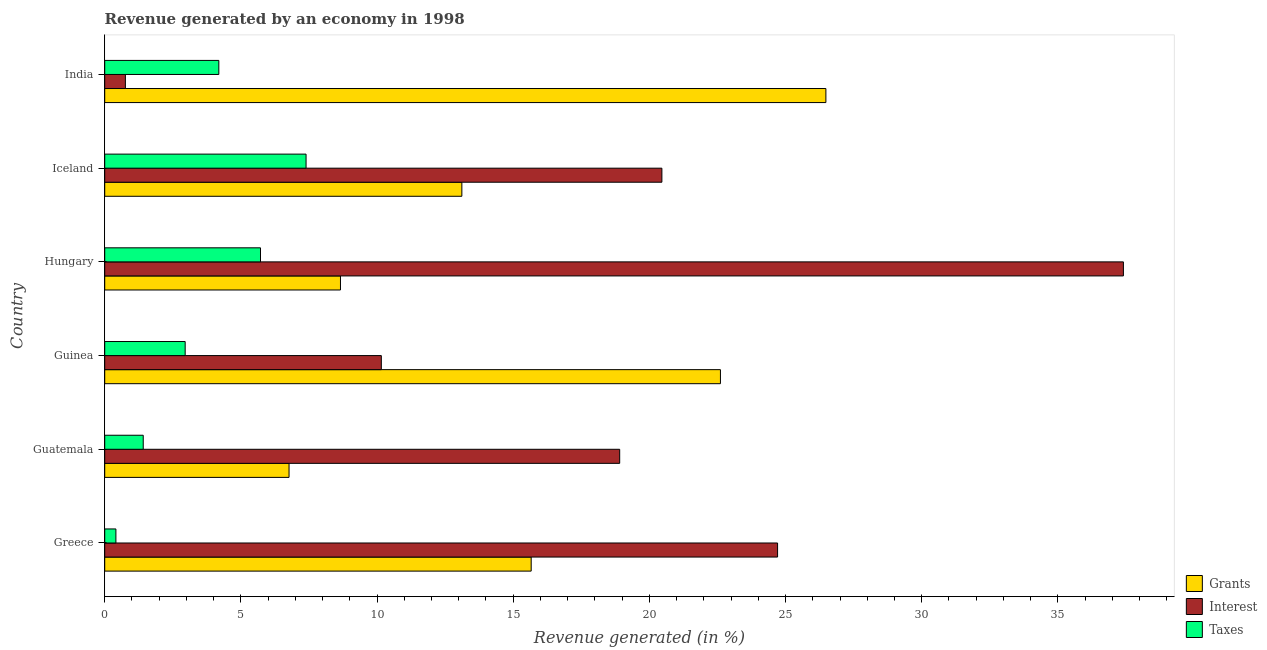How many groups of bars are there?
Give a very brief answer. 6. Are the number of bars on each tick of the Y-axis equal?
Offer a very short reply. Yes. What is the label of the 3rd group of bars from the top?
Provide a short and direct response. Hungary. What is the percentage of revenue generated by taxes in Guatemala?
Give a very brief answer. 1.41. Across all countries, what is the maximum percentage of revenue generated by interest?
Provide a short and direct response. 37.41. Across all countries, what is the minimum percentage of revenue generated by taxes?
Keep it short and to the point. 0.41. In which country was the percentage of revenue generated by grants maximum?
Ensure brevity in your answer.  India. In which country was the percentage of revenue generated by interest minimum?
Keep it short and to the point. India. What is the total percentage of revenue generated by interest in the graph?
Provide a succinct answer. 112.4. What is the difference between the percentage of revenue generated by taxes in Guinea and that in India?
Your response must be concise. -1.24. What is the difference between the percentage of revenue generated by grants in Greece and the percentage of revenue generated by taxes in Iceland?
Ensure brevity in your answer.  8.27. What is the average percentage of revenue generated by grants per country?
Give a very brief answer. 15.55. What is the difference between the percentage of revenue generated by taxes and percentage of revenue generated by grants in Greece?
Your answer should be compact. -15.25. In how many countries, is the percentage of revenue generated by grants greater than 26 %?
Your answer should be very brief. 1. What is the ratio of the percentage of revenue generated by taxes in Guatemala to that in India?
Give a very brief answer. 0.34. Is the difference between the percentage of revenue generated by taxes in Greece and India greater than the difference between the percentage of revenue generated by interest in Greece and India?
Give a very brief answer. No. What is the difference between the highest and the second highest percentage of revenue generated by interest?
Your answer should be compact. 12.7. What is the difference between the highest and the lowest percentage of revenue generated by grants?
Your response must be concise. 19.71. Is the sum of the percentage of revenue generated by grants in Hungary and Iceland greater than the maximum percentage of revenue generated by interest across all countries?
Offer a terse response. No. What does the 2nd bar from the top in Guatemala represents?
Your answer should be compact. Interest. What does the 2nd bar from the bottom in Guatemala represents?
Your response must be concise. Interest. Is it the case that in every country, the sum of the percentage of revenue generated by grants and percentage of revenue generated by interest is greater than the percentage of revenue generated by taxes?
Offer a very short reply. Yes. What is the difference between two consecutive major ticks on the X-axis?
Offer a very short reply. 5. Are the values on the major ticks of X-axis written in scientific E-notation?
Provide a short and direct response. No. Does the graph contain any zero values?
Ensure brevity in your answer.  No. What is the title of the graph?
Ensure brevity in your answer.  Revenue generated by an economy in 1998. Does "Ireland" appear as one of the legend labels in the graph?
Give a very brief answer. No. What is the label or title of the X-axis?
Your answer should be very brief. Revenue generated (in %). What is the Revenue generated (in %) of Grants in Greece?
Offer a terse response. 15.66. What is the Revenue generated (in %) in Interest in Greece?
Offer a terse response. 24.71. What is the Revenue generated (in %) of Taxes in Greece?
Your answer should be compact. 0.41. What is the Revenue generated (in %) in Grants in Guatemala?
Give a very brief answer. 6.77. What is the Revenue generated (in %) in Interest in Guatemala?
Offer a very short reply. 18.91. What is the Revenue generated (in %) of Taxes in Guatemala?
Ensure brevity in your answer.  1.41. What is the Revenue generated (in %) in Grants in Guinea?
Make the answer very short. 22.61. What is the Revenue generated (in %) in Interest in Guinea?
Your answer should be compact. 10.16. What is the Revenue generated (in %) of Taxes in Guinea?
Provide a succinct answer. 2.95. What is the Revenue generated (in %) of Grants in Hungary?
Give a very brief answer. 8.66. What is the Revenue generated (in %) in Interest in Hungary?
Ensure brevity in your answer.  37.41. What is the Revenue generated (in %) in Taxes in Hungary?
Provide a succinct answer. 5.72. What is the Revenue generated (in %) in Grants in Iceland?
Make the answer very short. 13.11. What is the Revenue generated (in %) in Interest in Iceland?
Offer a very short reply. 20.46. What is the Revenue generated (in %) of Taxes in Iceland?
Your answer should be very brief. 7.39. What is the Revenue generated (in %) of Grants in India?
Ensure brevity in your answer.  26.48. What is the Revenue generated (in %) in Interest in India?
Provide a short and direct response. 0.76. What is the Revenue generated (in %) of Taxes in India?
Offer a terse response. 4.19. Across all countries, what is the maximum Revenue generated (in %) of Grants?
Give a very brief answer. 26.48. Across all countries, what is the maximum Revenue generated (in %) in Interest?
Your answer should be very brief. 37.41. Across all countries, what is the maximum Revenue generated (in %) of Taxes?
Make the answer very short. 7.39. Across all countries, what is the minimum Revenue generated (in %) of Grants?
Offer a terse response. 6.77. Across all countries, what is the minimum Revenue generated (in %) of Interest?
Your response must be concise. 0.76. Across all countries, what is the minimum Revenue generated (in %) in Taxes?
Ensure brevity in your answer.  0.41. What is the total Revenue generated (in %) of Grants in the graph?
Your response must be concise. 93.29. What is the total Revenue generated (in %) in Interest in the graph?
Make the answer very short. 112.4. What is the total Revenue generated (in %) of Taxes in the graph?
Offer a very short reply. 22.08. What is the difference between the Revenue generated (in %) of Grants in Greece and that in Guatemala?
Keep it short and to the point. 8.89. What is the difference between the Revenue generated (in %) of Interest in Greece and that in Guatemala?
Ensure brevity in your answer.  5.8. What is the difference between the Revenue generated (in %) of Taxes in Greece and that in Guatemala?
Offer a terse response. -1. What is the difference between the Revenue generated (in %) in Grants in Greece and that in Guinea?
Offer a very short reply. -6.95. What is the difference between the Revenue generated (in %) of Interest in Greece and that in Guinea?
Your response must be concise. 14.55. What is the difference between the Revenue generated (in %) in Taxes in Greece and that in Guinea?
Give a very brief answer. -2.54. What is the difference between the Revenue generated (in %) in Grants in Greece and that in Hungary?
Your response must be concise. 7. What is the difference between the Revenue generated (in %) of Interest in Greece and that in Hungary?
Your answer should be compact. -12.7. What is the difference between the Revenue generated (in %) in Taxes in Greece and that in Hungary?
Keep it short and to the point. -5.31. What is the difference between the Revenue generated (in %) in Grants in Greece and that in Iceland?
Make the answer very short. 2.55. What is the difference between the Revenue generated (in %) in Interest in Greece and that in Iceland?
Offer a terse response. 4.25. What is the difference between the Revenue generated (in %) of Taxes in Greece and that in Iceland?
Provide a succinct answer. -6.98. What is the difference between the Revenue generated (in %) of Grants in Greece and that in India?
Give a very brief answer. -10.82. What is the difference between the Revenue generated (in %) in Interest in Greece and that in India?
Offer a very short reply. 23.95. What is the difference between the Revenue generated (in %) in Taxes in Greece and that in India?
Your answer should be very brief. -3.78. What is the difference between the Revenue generated (in %) in Grants in Guatemala and that in Guinea?
Make the answer very short. -15.84. What is the difference between the Revenue generated (in %) of Interest in Guatemala and that in Guinea?
Make the answer very short. 8.75. What is the difference between the Revenue generated (in %) in Taxes in Guatemala and that in Guinea?
Keep it short and to the point. -1.54. What is the difference between the Revenue generated (in %) in Grants in Guatemala and that in Hungary?
Offer a very short reply. -1.89. What is the difference between the Revenue generated (in %) in Interest in Guatemala and that in Hungary?
Offer a terse response. -18.5. What is the difference between the Revenue generated (in %) of Taxes in Guatemala and that in Hungary?
Keep it short and to the point. -4.31. What is the difference between the Revenue generated (in %) of Grants in Guatemala and that in Iceland?
Your answer should be compact. -6.35. What is the difference between the Revenue generated (in %) of Interest in Guatemala and that in Iceland?
Provide a succinct answer. -1.55. What is the difference between the Revenue generated (in %) of Taxes in Guatemala and that in Iceland?
Your answer should be very brief. -5.98. What is the difference between the Revenue generated (in %) in Grants in Guatemala and that in India?
Ensure brevity in your answer.  -19.71. What is the difference between the Revenue generated (in %) in Interest in Guatemala and that in India?
Keep it short and to the point. 18.15. What is the difference between the Revenue generated (in %) in Taxes in Guatemala and that in India?
Provide a succinct answer. -2.78. What is the difference between the Revenue generated (in %) of Grants in Guinea and that in Hungary?
Provide a succinct answer. 13.95. What is the difference between the Revenue generated (in %) in Interest in Guinea and that in Hungary?
Offer a very short reply. -27.25. What is the difference between the Revenue generated (in %) in Taxes in Guinea and that in Hungary?
Your response must be concise. -2.77. What is the difference between the Revenue generated (in %) in Grants in Guinea and that in Iceland?
Provide a short and direct response. 9.49. What is the difference between the Revenue generated (in %) of Interest in Guinea and that in Iceland?
Your answer should be compact. -10.3. What is the difference between the Revenue generated (in %) in Taxes in Guinea and that in Iceland?
Offer a terse response. -4.44. What is the difference between the Revenue generated (in %) of Grants in Guinea and that in India?
Offer a very short reply. -3.87. What is the difference between the Revenue generated (in %) in Interest in Guinea and that in India?
Your answer should be very brief. 9.4. What is the difference between the Revenue generated (in %) of Taxes in Guinea and that in India?
Your answer should be compact. -1.24. What is the difference between the Revenue generated (in %) of Grants in Hungary and that in Iceland?
Ensure brevity in your answer.  -4.46. What is the difference between the Revenue generated (in %) in Interest in Hungary and that in Iceland?
Provide a short and direct response. 16.95. What is the difference between the Revenue generated (in %) of Taxes in Hungary and that in Iceland?
Keep it short and to the point. -1.67. What is the difference between the Revenue generated (in %) of Grants in Hungary and that in India?
Your response must be concise. -17.82. What is the difference between the Revenue generated (in %) of Interest in Hungary and that in India?
Your answer should be very brief. 36.65. What is the difference between the Revenue generated (in %) in Taxes in Hungary and that in India?
Keep it short and to the point. 1.53. What is the difference between the Revenue generated (in %) of Grants in Iceland and that in India?
Keep it short and to the point. -13.37. What is the difference between the Revenue generated (in %) in Interest in Iceland and that in India?
Keep it short and to the point. 19.7. What is the difference between the Revenue generated (in %) of Taxes in Iceland and that in India?
Your answer should be compact. 3.2. What is the difference between the Revenue generated (in %) of Grants in Greece and the Revenue generated (in %) of Interest in Guatemala?
Make the answer very short. -3.25. What is the difference between the Revenue generated (in %) of Grants in Greece and the Revenue generated (in %) of Taxes in Guatemala?
Make the answer very short. 14.25. What is the difference between the Revenue generated (in %) of Interest in Greece and the Revenue generated (in %) of Taxes in Guatemala?
Give a very brief answer. 23.29. What is the difference between the Revenue generated (in %) of Grants in Greece and the Revenue generated (in %) of Interest in Guinea?
Provide a short and direct response. 5.5. What is the difference between the Revenue generated (in %) in Grants in Greece and the Revenue generated (in %) in Taxes in Guinea?
Offer a very short reply. 12.71. What is the difference between the Revenue generated (in %) of Interest in Greece and the Revenue generated (in %) of Taxes in Guinea?
Give a very brief answer. 21.75. What is the difference between the Revenue generated (in %) of Grants in Greece and the Revenue generated (in %) of Interest in Hungary?
Offer a terse response. -21.75. What is the difference between the Revenue generated (in %) in Grants in Greece and the Revenue generated (in %) in Taxes in Hungary?
Ensure brevity in your answer.  9.94. What is the difference between the Revenue generated (in %) in Interest in Greece and the Revenue generated (in %) in Taxes in Hungary?
Your answer should be compact. 18.99. What is the difference between the Revenue generated (in %) of Grants in Greece and the Revenue generated (in %) of Interest in Iceland?
Your answer should be very brief. -4.8. What is the difference between the Revenue generated (in %) in Grants in Greece and the Revenue generated (in %) in Taxes in Iceland?
Provide a short and direct response. 8.27. What is the difference between the Revenue generated (in %) in Interest in Greece and the Revenue generated (in %) in Taxes in Iceland?
Offer a terse response. 17.31. What is the difference between the Revenue generated (in %) in Grants in Greece and the Revenue generated (in %) in Interest in India?
Give a very brief answer. 14.9. What is the difference between the Revenue generated (in %) in Grants in Greece and the Revenue generated (in %) in Taxes in India?
Make the answer very short. 11.47. What is the difference between the Revenue generated (in %) of Interest in Greece and the Revenue generated (in %) of Taxes in India?
Keep it short and to the point. 20.52. What is the difference between the Revenue generated (in %) in Grants in Guatemala and the Revenue generated (in %) in Interest in Guinea?
Ensure brevity in your answer.  -3.39. What is the difference between the Revenue generated (in %) of Grants in Guatemala and the Revenue generated (in %) of Taxes in Guinea?
Give a very brief answer. 3.81. What is the difference between the Revenue generated (in %) of Interest in Guatemala and the Revenue generated (in %) of Taxes in Guinea?
Your answer should be very brief. 15.96. What is the difference between the Revenue generated (in %) in Grants in Guatemala and the Revenue generated (in %) in Interest in Hungary?
Provide a succinct answer. -30.64. What is the difference between the Revenue generated (in %) of Grants in Guatemala and the Revenue generated (in %) of Taxes in Hungary?
Your answer should be very brief. 1.05. What is the difference between the Revenue generated (in %) of Interest in Guatemala and the Revenue generated (in %) of Taxes in Hungary?
Your answer should be compact. 13.19. What is the difference between the Revenue generated (in %) of Grants in Guatemala and the Revenue generated (in %) of Interest in Iceland?
Offer a very short reply. -13.69. What is the difference between the Revenue generated (in %) in Grants in Guatemala and the Revenue generated (in %) in Taxes in Iceland?
Keep it short and to the point. -0.62. What is the difference between the Revenue generated (in %) in Interest in Guatemala and the Revenue generated (in %) in Taxes in Iceland?
Give a very brief answer. 11.52. What is the difference between the Revenue generated (in %) in Grants in Guatemala and the Revenue generated (in %) in Interest in India?
Ensure brevity in your answer.  6.01. What is the difference between the Revenue generated (in %) in Grants in Guatemala and the Revenue generated (in %) in Taxes in India?
Provide a short and direct response. 2.58. What is the difference between the Revenue generated (in %) in Interest in Guatemala and the Revenue generated (in %) in Taxes in India?
Provide a short and direct response. 14.72. What is the difference between the Revenue generated (in %) of Grants in Guinea and the Revenue generated (in %) of Interest in Hungary?
Offer a terse response. -14.8. What is the difference between the Revenue generated (in %) of Grants in Guinea and the Revenue generated (in %) of Taxes in Hungary?
Your response must be concise. 16.89. What is the difference between the Revenue generated (in %) of Interest in Guinea and the Revenue generated (in %) of Taxes in Hungary?
Your answer should be very brief. 4.44. What is the difference between the Revenue generated (in %) of Grants in Guinea and the Revenue generated (in %) of Interest in Iceland?
Keep it short and to the point. 2.15. What is the difference between the Revenue generated (in %) in Grants in Guinea and the Revenue generated (in %) in Taxes in Iceland?
Your answer should be compact. 15.22. What is the difference between the Revenue generated (in %) in Interest in Guinea and the Revenue generated (in %) in Taxes in Iceland?
Your answer should be very brief. 2.76. What is the difference between the Revenue generated (in %) in Grants in Guinea and the Revenue generated (in %) in Interest in India?
Your response must be concise. 21.85. What is the difference between the Revenue generated (in %) of Grants in Guinea and the Revenue generated (in %) of Taxes in India?
Give a very brief answer. 18.42. What is the difference between the Revenue generated (in %) of Interest in Guinea and the Revenue generated (in %) of Taxes in India?
Keep it short and to the point. 5.97. What is the difference between the Revenue generated (in %) in Grants in Hungary and the Revenue generated (in %) in Interest in Iceland?
Your response must be concise. -11.8. What is the difference between the Revenue generated (in %) of Grants in Hungary and the Revenue generated (in %) of Taxes in Iceland?
Provide a succinct answer. 1.26. What is the difference between the Revenue generated (in %) in Interest in Hungary and the Revenue generated (in %) in Taxes in Iceland?
Make the answer very short. 30.01. What is the difference between the Revenue generated (in %) in Grants in Hungary and the Revenue generated (in %) in Interest in India?
Provide a short and direct response. 7.9. What is the difference between the Revenue generated (in %) in Grants in Hungary and the Revenue generated (in %) in Taxes in India?
Ensure brevity in your answer.  4.47. What is the difference between the Revenue generated (in %) of Interest in Hungary and the Revenue generated (in %) of Taxes in India?
Provide a short and direct response. 33.22. What is the difference between the Revenue generated (in %) in Grants in Iceland and the Revenue generated (in %) in Interest in India?
Make the answer very short. 12.35. What is the difference between the Revenue generated (in %) in Grants in Iceland and the Revenue generated (in %) in Taxes in India?
Your answer should be very brief. 8.92. What is the difference between the Revenue generated (in %) in Interest in Iceland and the Revenue generated (in %) in Taxes in India?
Your answer should be compact. 16.27. What is the average Revenue generated (in %) of Grants per country?
Keep it short and to the point. 15.55. What is the average Revenue generated (in %) of Interest per country?
Your response must be concise. 18.73. What is the average Revenue generated (in %) in Taxes per country?
Give a very brief answer. 3.68. What is the difference between the Revenue generated (in %) of Grants and Revenue generated (in %) of Interest in Greece?
Give a very brief answer. -9.05. What is the difference between the Revenue generated (in %) in Grants and Revenue generated (in %) in Taxes in Greece?
Make the answer very short. 15.25. What is the difference between the Revenue generated (in %) in Interest and Revenue generated (in %) in Taxes in Greece?
Your answer should be compact. 24.3. What is the difference between the Revenue generated (in %) of Grants and Revenue generated (in %) of Interest in Guatemala?
Keep it short and to the point. -12.14. What is the difference between the Revenue generated (in %) of Grants and Revenue generated (in %) of Taxes in Guatemala?
Give a very brief answer. 5.35. What is the difference between the Revenue generated (in %) in Interest and Revenue generated (in %) in Taxes in Guatemala?
Give a very brief answer. 17.5. What is the difference between the Revenue generated (in %) in Grants and Revenue generated (in %) in Interest in Guinea?
Your answer should be compact. 12.45. What is the difference between the Revenue generated (in %) in Grants and Revenue generated (in %) in Taxes in Guinea?
Ensure brevity in your answer.  19.66. What is the difference between the Revenue generated (in %) in Interest and Revenue generated (in %) in Taxes in Guinea?
Offer a terse response. 7.2. What is the difference between the Revenue generated (in %) in Grants and Revenue generated (in %) in Interest in Hungary?
Offer a terse response. -28.75. What is the difference between the Revenue generated (in %) of Grants and Revenue generated (in %) of Taxes in Hungary?
Your response must be concise. 2.94. What is the difference between the Revenue generated (in %) of Interest and Revenue generated (in %) of Taxes in Hungary?
Keep it short and to the point. 31.68. What is the difference between the Revenue generated (in %) in Grants and Revenue generated (in %) in Interest in Iceland?
Provide a succinct answer. -7.34. What is the difference between the Revenue generated (in %) in Grants and Revenue generated (in %) in Taxes in Iceland?
Give a very brief answer. 5.72. What is the difference between the Revenue generated (in %) of Interest and Revenue generated (in %) of Taxes in Iceland?
Offer a terse response. 13.07. What is the difference between the Revenue generated (in %) in Grants and Revenue generated (in %) in Interest in India?
Provide a short and direct response. 25.72. What is the difference between the Revenue generated (in %) in Grants and Revenue generated (in %) in Taxes in India?
Offer a terse response. 22.29. What is the difference between the Revenue generated (in %) of Interest and Revenue generated (in %) of Taxes in India?
Keep it short and to the point. -3.43. What is the ratio of the Revenue generated (in %) in Grants in Greece to that in Guatemala?
Give a very brief answer. 2.31. What is the ratio of the Revenue generated (in %) in Interest in Greece to that in Guatemala?
Offer a very short reply. 1.31. What is the ratio of the Revenue generated (in %) of Taxes in Greece to that in Guatemala?
Provide a short and direct response. 0.29. What is the ratio of the Revenue generated (in %) in Grants in Greece to that in Guinea?
Provide a succinct answer. 0.69. What is the ratio of the Revenue generated (in %) in Interest in Greece to that in Guinea?
Your answer should be very brief. 2.43. What is the ratio of the Revenue generated (in %) in Taxes in Greece to that in Guinea?
Your response must be concise. 0.14. What is the ratio of the Revenue generated (in %) of Grants in Greece to that in Hungary?
Provide a succinct answer. 1.81. What is the ratio of the Revenue generated (in %) of Interest in Greece to that in Hungary?
Keep it short and to the point. 0.66. What is the ratio of the Revenue generated (in %) of Taxes in Greece to that in Hungary?
Offer a terse response. 0.07. What is the ratio of the Revenue generated (in %) of Grants in Greece to that in Iceland?
Ensure brevity in your answer.  1.19. What is the ratio of the Revenue generated (in %) of Interest in Greece to that in Iceland?
Provide a short and direct response. 1.21. What is the ratio of the Revenue generated (in %) in Taxes in Greece to that in Iceland?
Provide a short and direct response. 0.06. What is the ratio of the Revenue generated (in %) in Grants in Greece to that in India?
Ensure brevity in your answer.  0.59. What is the ratio of the Revenue generated (in %) of Interest in Greece to that in India?
Keep it short and to the point. 32.54. What is the ratio of the Revenue generated (in %) in Taxes in Greece to that in India?
Your answer should be compact. 0.1. What is the ratio of the Revenue generated (in %) of Grants in Guatemala to that in Guinea?
Your response must be concise. 0.3. What is the ratio of the Revenue generated (in %) in Interest in Guatemala to that in Guinea?
Give a very brief answer. 1.86. What is the ratio of the Revenue generated (in %) in Taxes in Guatemala to that in Guinea?
Ensure brevity in your answer.  0.48. What is the ratio of the Revenue generated (in %) of Grants in Guatemala to that in Hungary?
Your answer should be very brief. 0.78. What is the ratio of the Revenue generated (in %) in Interest in Guatemala to that in Hungary?
Your answer should be very brief. 0.51. What is the ratio of the Revenue generated (in %) in Taxes in Guatemala to that in Hungary?
Offer a terse response. 0.25. What is the ratio of the Revenue generated (in %) of Grants in Guatemala to that in Iceland?
Your response must be concise. 0.52. What is the ratio of the Revenue generated (in %) in Interest in Guatemala to that in Iceland?
Keep it short and to the point. 0.92. What is the ratio of the Revenue generated (in %) of Taxes in Guatemala to that in Iceland?
Give a very brief answer. 0.19. What is the ratio of the Revenue generated (in %) in Grants in Guatemala to that in India?
Offer a terse response. 0.26. What is the ratio of the Revenue generated (in %) in Interest in Guatemala to that in India?
Your response must be concise. 24.9. What is the ratio of the Revenue generated (in %) of Taxes in Guatemala to that in India?
Give a very brief answer. 0.34. What is the ratio of the Revenue generated (in %) of Grants in Guinea to that in Hungary?
Ensure brevity in your answer.  2.61. What is the ratio of the Revenue generated (in %) of Interest in Guinea to that in Hungary?
Provide a succinct answer. 0.27. What is the ratio of the Revenue generated (in %) in Taxes in Guinea to that in Hungary?
Offer a terse response. 0.52. What is the ratio of the Revenue generated (in %) of Grants in Guinea to that in Iceland?
Your answer should be very brief. 1.72. What is the ratio of the Revenue generated (in %) of Interest in Guinea to that in Iceland?
Your response must be concise. 0.5. What is the ratio of the Revenue generated (in %) in Taxes in Guinea to that in Iceland?
Make the answer very short. 0.4. What is the ratio of the Revenue generated (in %) of Grants in Guinea to that in India?
Offer a very short reply. 0.85. What is the ratio of the Revenue generated (in %) of Interest in Guinea to that in India?
Ensure brevity in your answer.  13.38. What is the ratio of the Revenue generated (in %) in Taxes in Guinea to that in India?
Ensure brevity in your answer.  0.7. What is the ratio of the Revenue generated (in %) of Grants in Hungary to that in Iceland?
Make the answer very short. 0.66. What is the ratio of the Revenue generated (in %) of Interest in Hungary to that in Iceland?
Provide a succinct answer. 1.83. What is the ratio of the Revenue generated (in %) of Taxes in Hungary to that in Iceland?
Keep it short and to the point. 0.77. What is the ratio of the Revenue generated (in %) of Grants in Hungary to that in India?
Provide a succinct answer. 0.33. What is the ratio of the Revenue generated (in %) of Interest in Hungary to that in India?
Provide a short and direct response. 49.26. What is the ratio of the Revenue generated (in %) in Taxes in Hungary to that in India?
Keep it short and to the point. 1.37. What is the ratio of the Revenue generated (in %) of Grants in Iceland to that in India?
Keep it short and to the point. 0.5. What is the ratio of the Revenue generated (in %) in Interest in Iceland to that in India?
Make the answer very short. 26.94. What is the ratio of the Revenue generated (in %) of Taxes in Iceland to that in India?
Offer a very short reply. 1.76. What is the difference between the highest and the second highest Revenue generated (in %) in Grants?
Ensure brevity in your answer.  3.87. What is the difference between the highest and the second highest Revenue generated (in %) in Interest?
Your answer should be compact. 12.7. What is the difference between the highest and the second highest Revenue generated (in %) of Taxes?
Ensure brevity in your answer.  1.67. What is the difference between the highest and the lowest Revenue generated (in %) in Grants?
Make the answer very short. 19.71. What is the difference between the highest and the lowest Revenue generated (in %) in Interest?
Offer a very short reply. 36.65. What is the difference between the highest and the lowest Revenue generated (in %) of Taxes?
Provide a short and direct response. 6.98. 